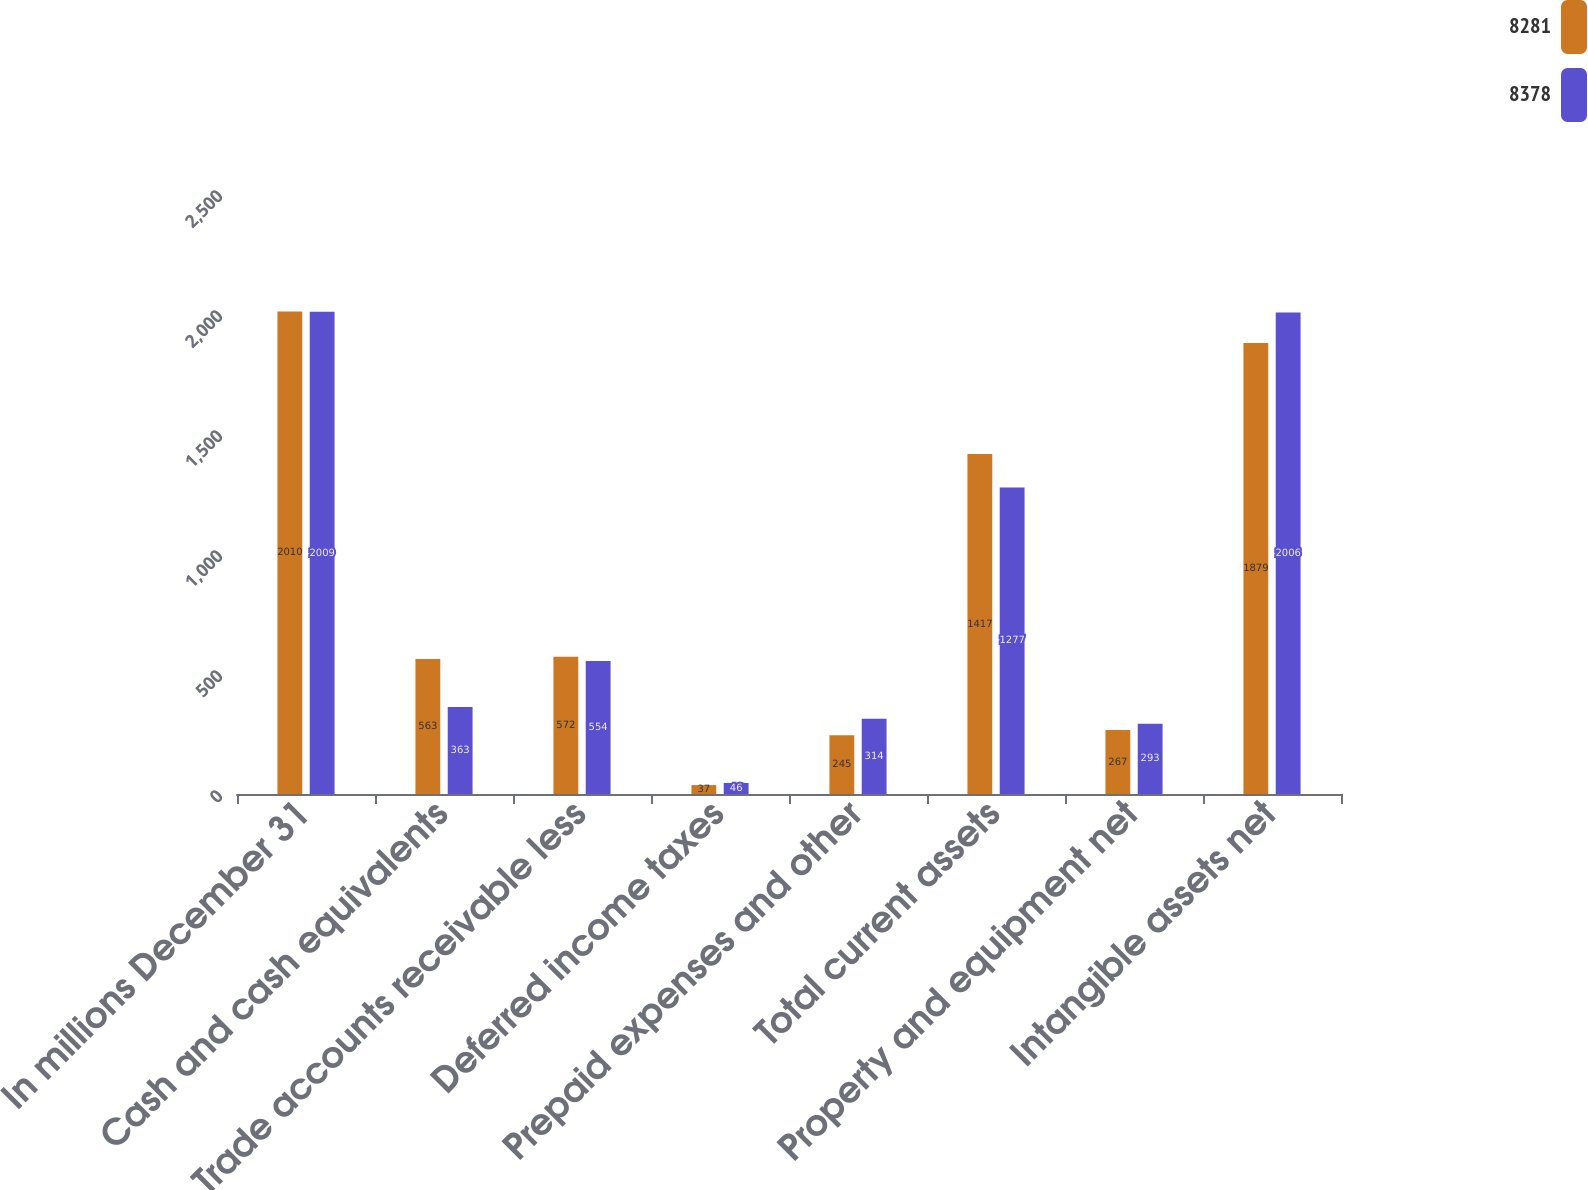Convert chart. <chart><loc_0><loc_0><loc_500><loc_500><stacked_bar_chart><ecel><fcel>In millions December 31<fcel>Cash and cash equivalents<fcel>Trade accounts receivable less<fcel>Deferred income taxes<fcel>Prepaid expenses and other<fcel>Total current assets<fcel>Property and equipment net<fcel>Intangible assets net<nl><fcel>8281<fcel>2010<fcel>563<fcel>572<fcel>37<fcel>245<fcel>1417<fcel>267<fcel>1879<nl><fcel>8378<fcel>2009<fcel>363<fcel>554<fcel>46<fcel>314<fcel>1277<fcel>293<fcel>2006<nl></chart> 